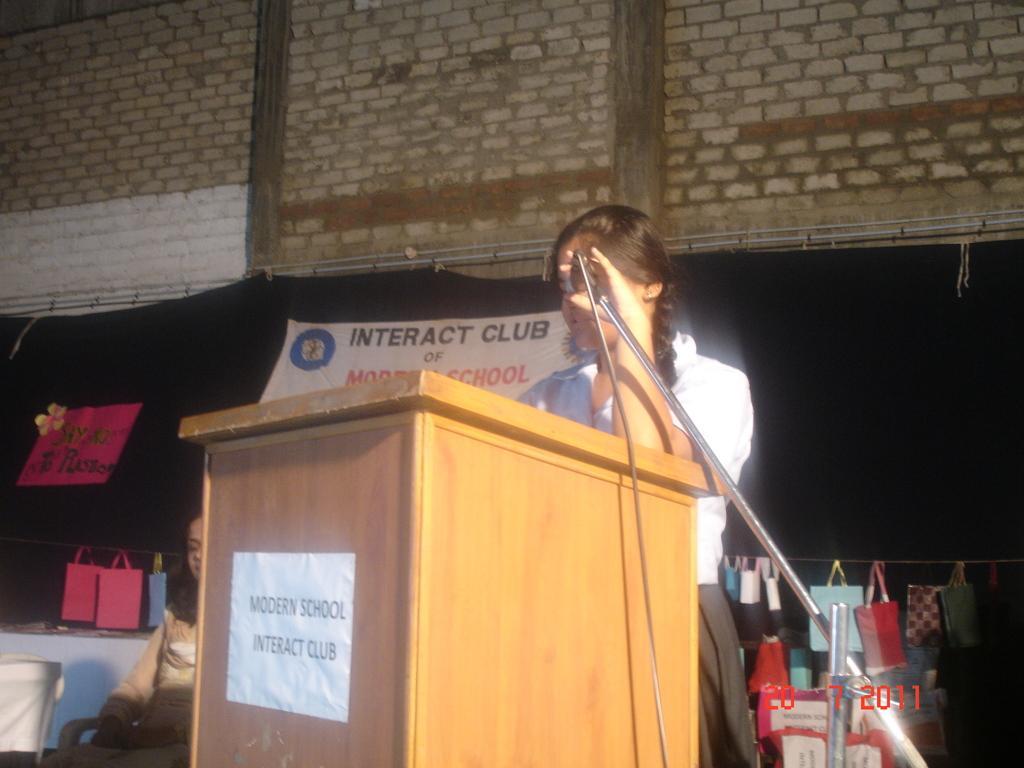Please provide a concise description of this image. In the picture there is a table in front of the table a girl is standing and giving the speech beside that there is a woman sitting on the chair behind her there is a black color cloth in front of that there are few items kept in front of the cloth in the background there is a brick wall. 